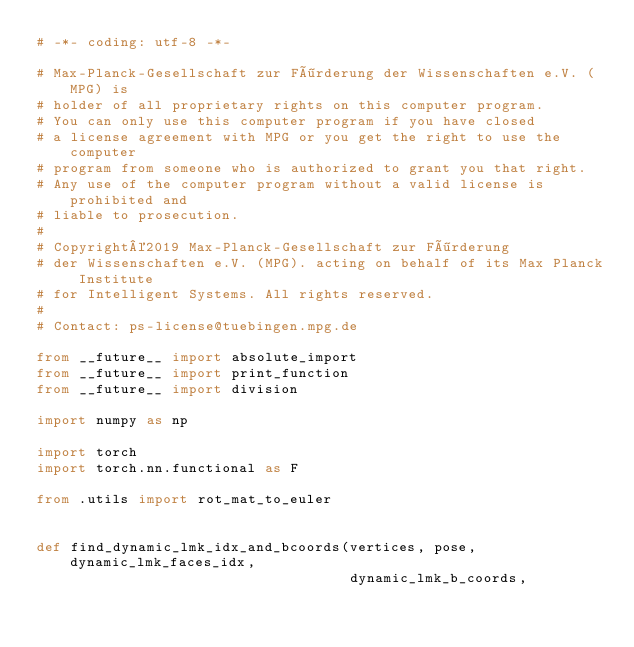Convert code to text. <code><loc_0><loc_0><loc_500><loc_500><_Python_># -*- coding: utf-8 -*-

# Max-Planck-Gesellschaft zur Förderung der Wissenschaften e.V. (MPG) is
# holder of all proprietary rights on this computer program.
# You can only use this computer program if you have closed
# a license agreement with MPG or you get the right to use the computer
# program from someone who is authorized to grant you that right.
# Any use of the computer program without a valid license is prohibited and
# liable to prosecution.
#
# Copyright©2019 Max-Planck-Gesellschaft zur Förderung
# der Wissenschaften e.V. (MPG). acting on behalf of its Max Planck Institute
# for Intelligent Systems. All rights reserved.
#
# Contact: ps-license@tuebingen.mpg.de

from __future__ import absolute_import
from __future__ import print_function
from __future__ import division

import numpy as np

import torch
import torch.nn.functional as F

from .utils import rot_mat_to_euler


def find_dynamic_lmk_idx_and_bcoords(vertices, pose, dynamic_lmk_faces_idx,
                                     dynamic_lmk_b_coords,</code> 